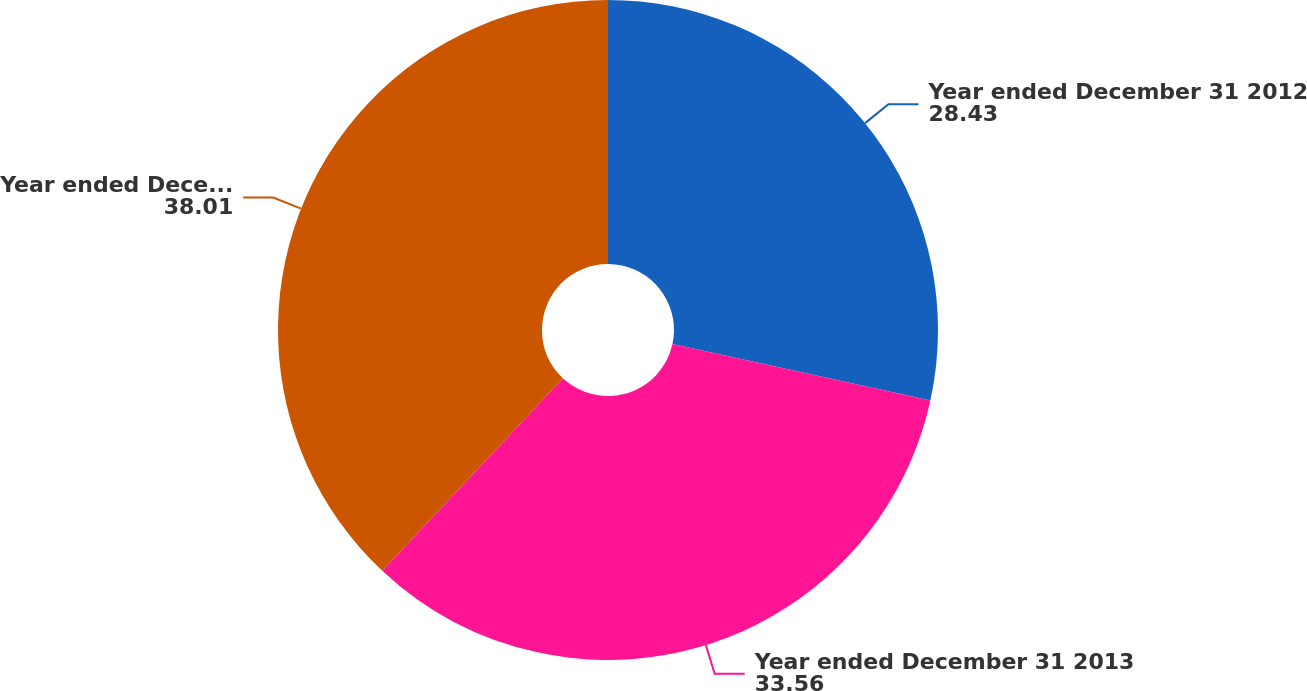<chart> <loc_0><loc_0><loc_500><loc_500><pie_chart><fcel>Year ended December 31 2012<fcel>Year ended December 31 2013<fcel>Year ended December 31 2014<nl><fcel>28.43%<fcel>33.56%<fcel>38.01%<nl></chart> 